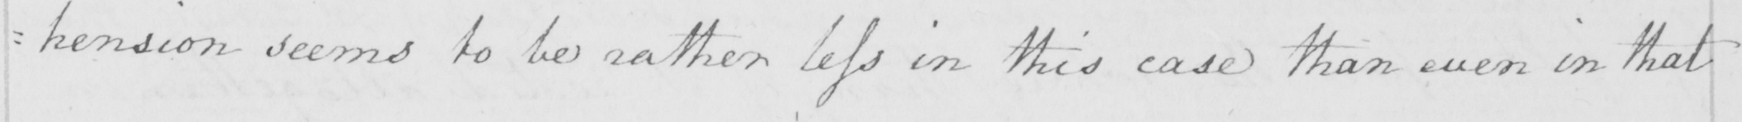Can you tell me what this handwritten text says? =hension seems to be rather less in this case than even in that 